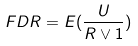Convert formula to latex. <formula><loc_0><loc_0><loc_500><loc_500>F D R = E ( \frac { U } { R \vee 1 } )</formula> 